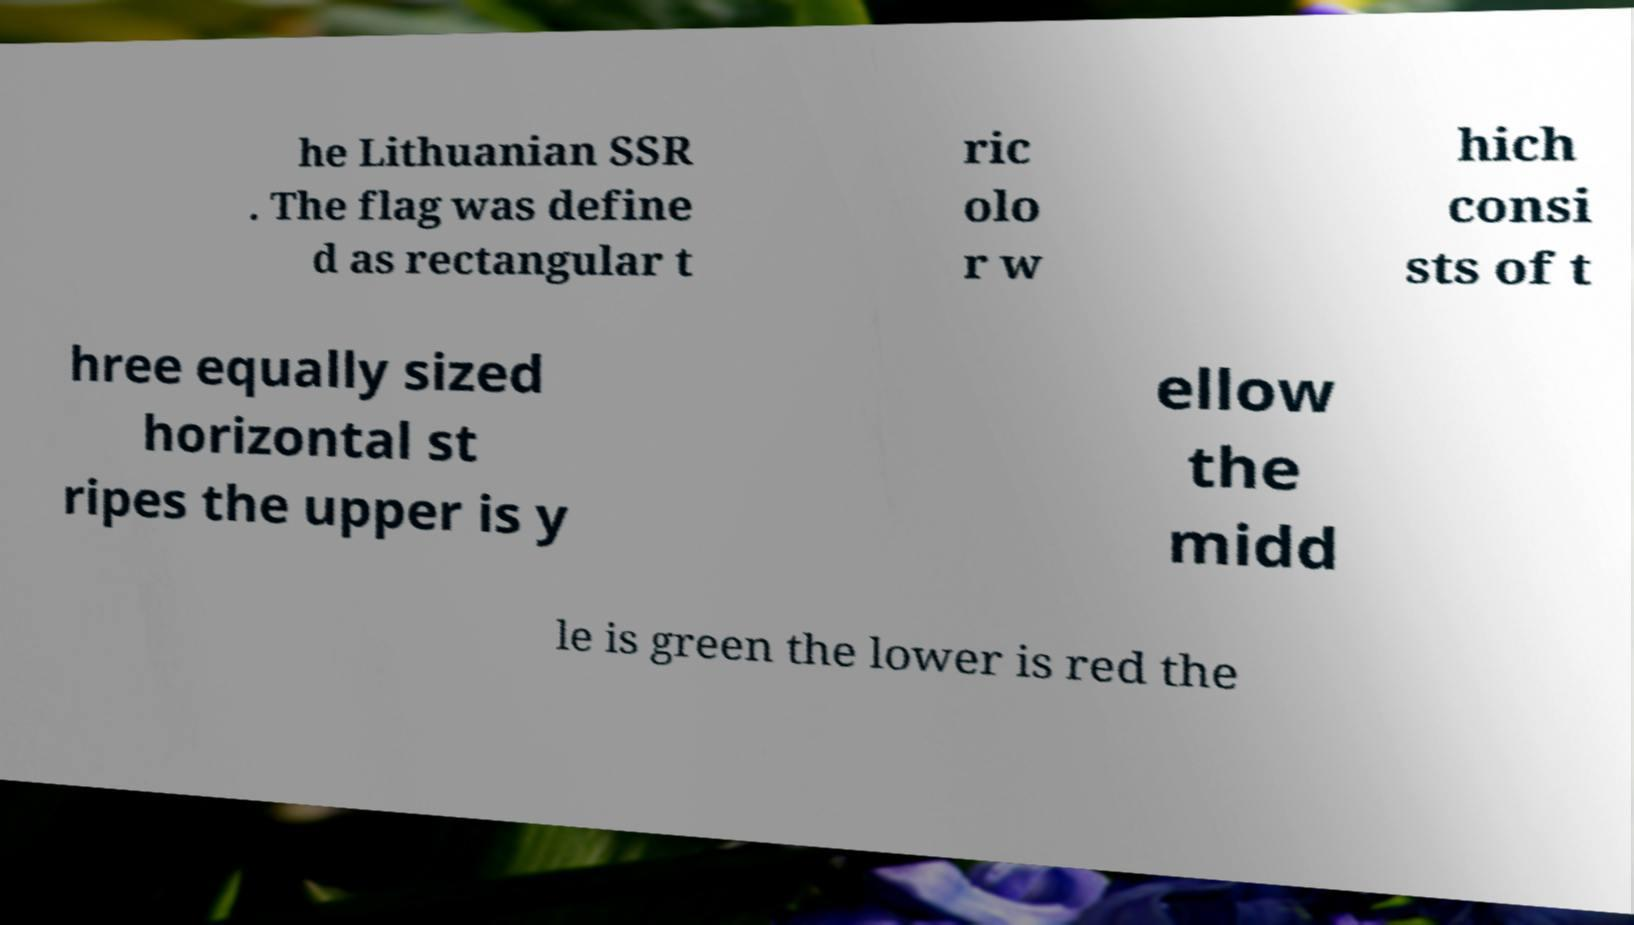I need the written content from this picture converted into text. Can you do that? he Lithuanian SSR . The flag was define d as rectangular t ric olo r w hich consi sts of t hree equally sized horizontal st ripes the upper is y ellow the midd le is green the lower is red the 